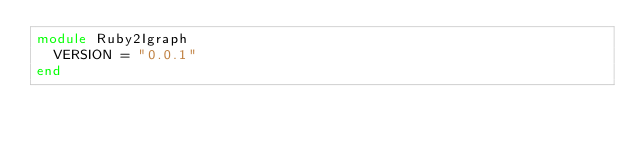<code> <loc_0><loc_0><loc_500><loc_500><_Ruby_>module Ruby2Igraph
  VERSION = "0.0.1"
end
</code> 